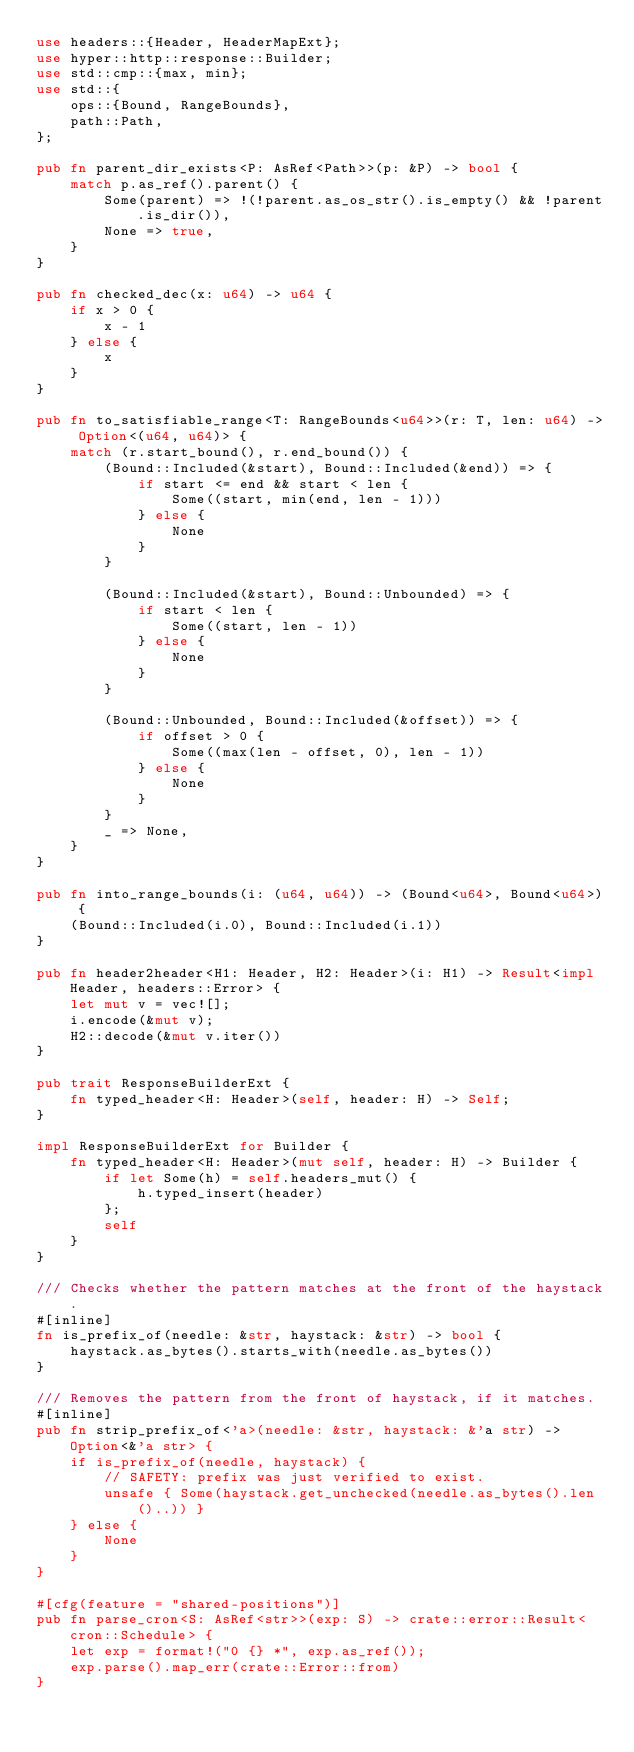Convert code to text. <code><loc_0><loc_0><loc_500><loc_500><_Rust_>use headers::{Header, HeaderMapExt};
use hyper::http::response::Builder;
use std::cmp::{max, min};
use std::{
    ops::{Bound, RangeBounds},
    path::Path,
};

pub fn parent_dir_exists<P: AsRef<Path>>(p: &P) -> bool {
    match p.as_ref().parent() {
        Some(parent) => !(!parent.as_os_str().is_empty() && !parent.is_dir()),
        None => true,
    }
}

pub fn checked_dec(x: u64) -> u64 {
    if x > 0 {
        x - 1
    } else {
        x
    }
}

pub fn to_satisfiable_range<T: RangeBounds<u64>>(r: T, len: u64) -> Option<(u64, u64)> {
    match (r.start_bound(), r.end_bound()) {
        (Bound::Included(&start), Bound::Included(&end)) => {
            if start <= end && start < len {
                Some((start, min(end, len - 1)))
            } else {
                None
            }
        }

        (Bound::Included(&start), Bound::Unbounded) => {
            if start < len {
                Some((start, len - 1))
            } else {
                None
            }
        }

        (Bound::Unbounded, Bound::Included(&offset)) => {
            if offset > 0 {
                Some((max(len - offset, 0), len - 1))
            } else {
                None
            }
        }
        _ => None,
    }
}

pub fn into_range_bounds(i: (u64, u64)) -> (Bound<u64>, Bound<u64>) {
    (Bound::Included(i.0), Bound::Included(i.1))
}

pub fn header2header<H1: Header, H2: Header>(i: H1) -> Result<impl Header, headers::Error> {
    let mut v = vec![];
    i.encode(&mut v);
    H2::decode(&mut v.iter())
}

pub trait ResponseBuilderExt {
    fn typed_header<H: Header>(self, header: H) -> Self;
}

impl ResponseBuilderExt for Builder {
    fn typed_header<H: Header>(mut self, header: H) -> Builder {
        if let Some(h) = self.headers_mut() {
            h.typed_insert(header)
        };
        self
    }
}

/// Checks whether the pattern matches at the front of the haystack.
#[inline]
fn is_prefix_of(needle: &str, haystack: &str) -> bool {
    haystack.as_bytes().starts_with(needle.as_bytes())
}

/// Removes the pattern from the front of haystack, if it matches.
#[inline]
pub fn strip_prefix_of<'a>(needle: &str, haystack: &'a str) -> Option<&'a str> {
    if is_prefix_of(needle, haystack) {
        // SAFETY: prefix was just verified to exist.
        unsafe { Some(haystack.get_unchecked(needle.as_bytes().len()..)) }
    } else {
        None
    }
}

#[cfg(feature = "shared-positions")]
pub fn parse_cron<S: AsRef<str>>(exp: S) -> crate::error::Result<cron::Schedule> {
    let exp = format!("0 {} *", exp.as_ref());
    exp.parse().map_err(crate::Error::from)
}
</code> 